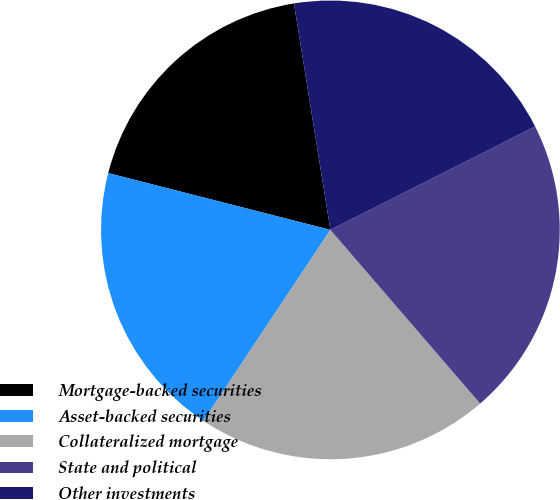Convert chart to OTSL. <chart><loc_0><loc_0><loc_500><loc_500><pie_chart><fcel>Mortgage-backed securities<fcel>Asset-backed securities<fcel>Collateralized mortgage<fcel>State and political<fcel>Other investments<nl><fcel>18.48%<fcel>19.65%<fcel>20.66%<fcel>21.12%<fcel>20.1%<nl></chart> 